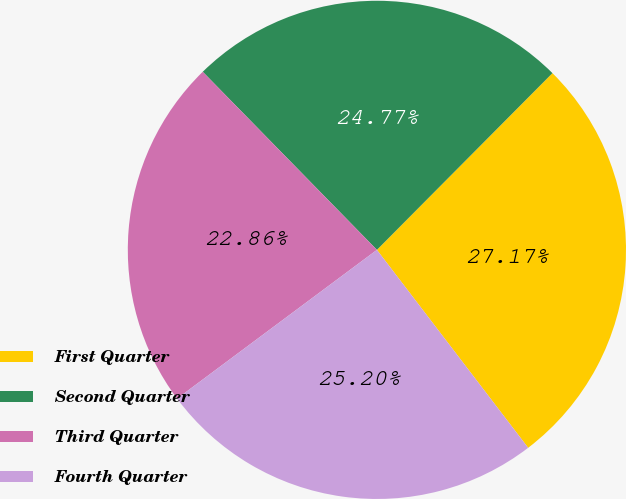Convert chart to OTSL. <chart><loc_0><loc_0><loc_500><loc_500><pie_chart><fcel>First Quarter<fcel>Second Quarter<fcel>Third Quarter<fcel>Fourth Quarter<nl><fcel>27.17%<fcel>24.77%<fcel>22.86%<fcel>25.2%<nl></chart> 